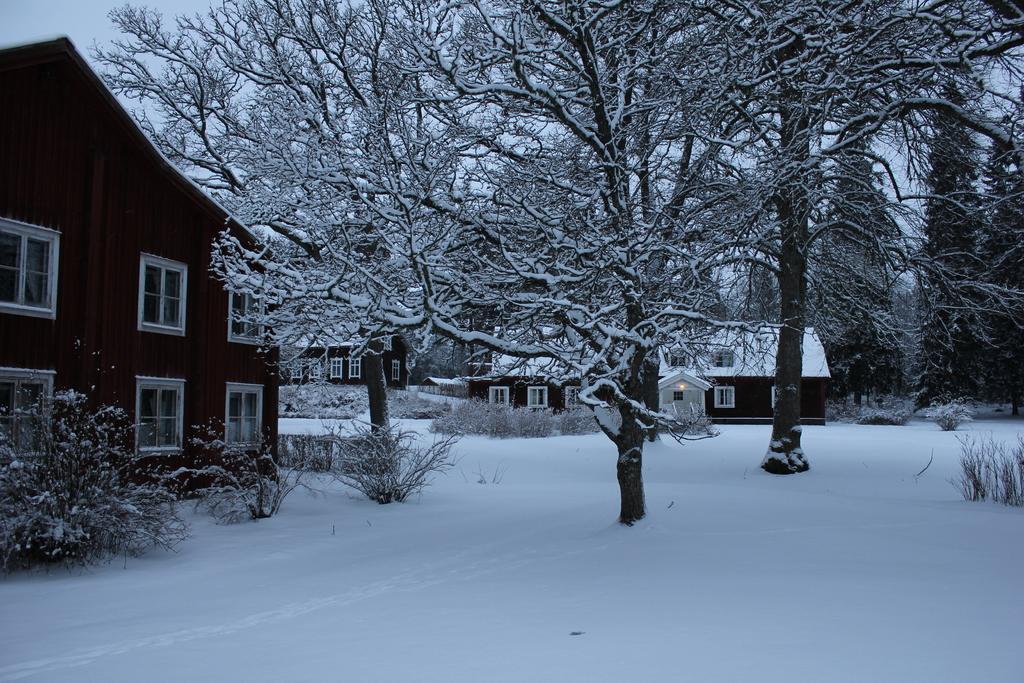Describe this image in one or two sentences. In this picture I can see some houses, trees fully covered with snow. 